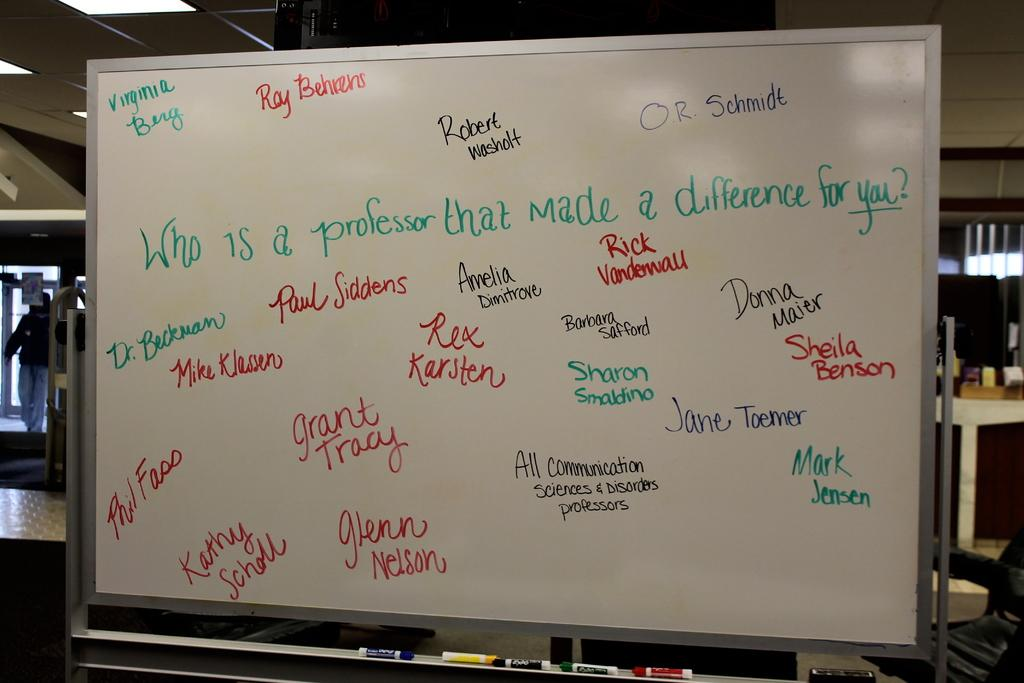<image>
Present a compact description of the photo's key features. "Who is a professor that made a difference for you?" is written on a white board. 